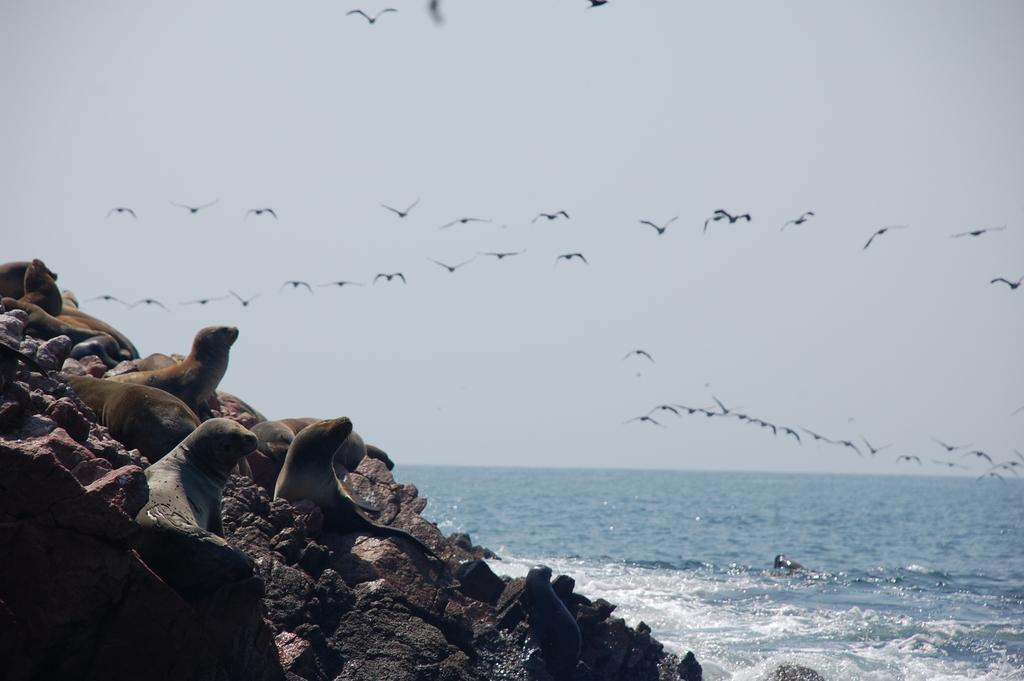What animals can be seen on the rocks in the image? There are seals on the rocks on the left side of the image. What is visible on the right side of the image? There is water visible on the right side of the image. What is happening in the air in the image? Birds are flying in the air in the image. What part of the natural environment is visible in the image? The sky is visible in the image. Can you tell me how many flowers are blooming in the image? There are no flowers present in the image. What type of tank can be seen in the image? There is no tank present in the image. 